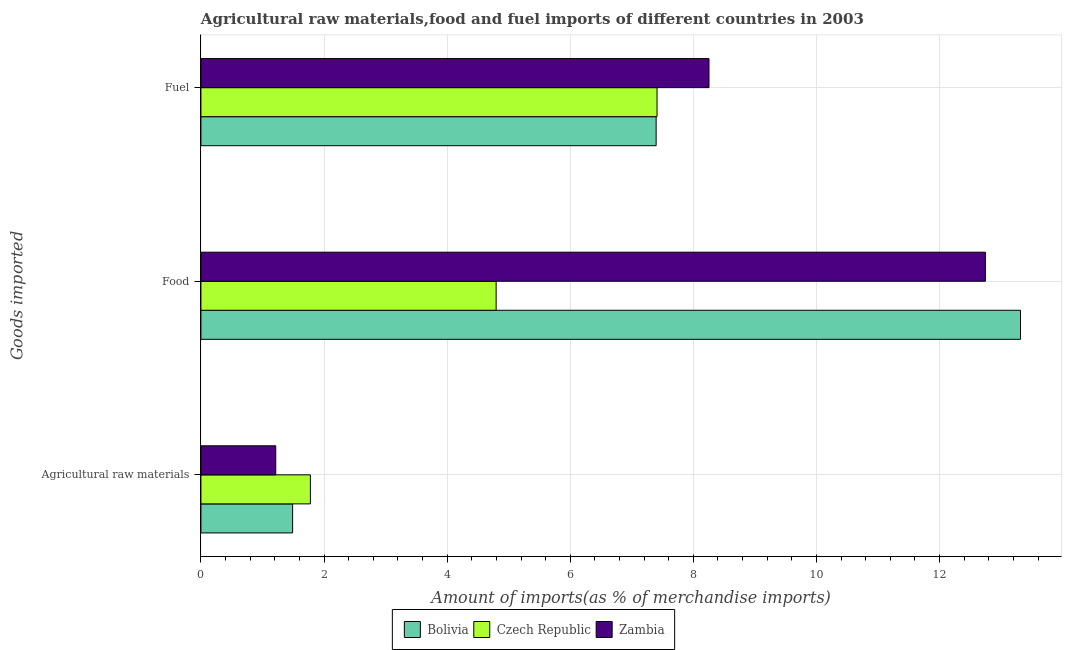How many different coloured bars are there?
Ensure brevity in your answer.  3. How many groups of bars are there?
Give a very brief answer. 3. Are the number of bars on each tick of the Y-axis equal?
Give a very brief answer. Yes. How many bars are there on the 3rd tick from the bottom?
Offer a very short reply. 3. What is the label of the 3rd group of bars from the top?
Provide a succinct answer. Agricultural raw materials. What is the percentage of raw materials imports in Zambia?
Make the answer very short. 1.22. Across all countries, what is the maximum percentage of food imports?
Provide a short and direct response. 13.31. Across all countries, what is the minimum percentage of food imports?
Offer a terse response. 4.8. In which country was the percentage of fuel imports maximum?
Offer a terse response. Zambia. In which country was the percentage of raw materials imports minimum?
Your response must be concise. Zambia. What is the total percentage of food imports in the graph?
Your answer should be compact. 30.86. What is the difference between the percentage of fuel imports in Czech Republic and that in Bolivia?
Your answer should be compact. 0.01. What is the difference between the percentage of raw materials imports in Zambia and the percentage of fuel imports in Czech Republic?
Provide a succinct answer. -6.19. What is the average percentage of raw materials imports per country?
Ensure brevity in your answer.  1.49. What is the difference between the percentage of raw materials imports and percentage of food imports in Bolivia?
Your response must be concise. -11.82. In how many countries, is the percentage of fuel imports greater than 9.2 %?
Provide a short and direct response. 0. What is the ratio of the percentage of fuel imports in Czech Republic to that in Bolivia?
Ensure brevity in your answer.  1. Is the percentage of food imports in Bolivia less than that in Zambia?
Make the answer very short. No. What is the difference between the highest and the second highest percentage of raw materials imports?
Ensure brevity in your answer.  0.29. What is the difference between the highest and the lowest percentage of fuel imports?
Your answer should be compact. 0.86. What does the 3rd bar from the top in Fuel represents?
Offer a very short reply. Bolivia. What does the 1st bar from the bottom in Fuel represents?
Provide a succinct answer. Bolivia. Is it the case that in every country, the sum of the percentage of raw materials imports and percentage of food imports is greater than the percentage of fuel imports?
Provide a short and direct response. No. How many bars are there?
Give a very brief answer. 9. Are all the bars in the graph horizontal?
Ensure brevity in your answer.  Yes. What is the difference between two consecutive major ticks on the X-axis?
Make the answer very short. 2. Does the graph contain grids?
Provide a succinct answer. Yes. How many legend labels are there?
Your answer should be compact. 3. What is the title of the graph?
Provide a short and direct response. Agricultural raw materials,food and fuel imports of different countries in 2003. Does "Central Europe" appear as one of the legend labels in the graph?
Offer a very short reply. No. What is the label or title of the X-axis?
Provide a succinct answer. Amount of imports(as % of merchandise imports). What is the label or title of the Y-axis?
Your answer should be very brief. Goods imported. What is the Amount of imports(as % of merchandise imports) of Bolivia in Agricultural raw materials?
Offer a very short reply. 1.49. What is the Amount of imports(as % of merchandise imports) of Czech Republic in Agricultural raw materials?
Give a very brief answer. 1.78. What is the Amount of imports(as % of merchandise imports) of Zambia in Agricultural raw materials?
Offer a terse response. 1.22. What is the Amount of imports(as % of merchandise imports) in Bolivia in Food?
Provide a short and direct response. 13.31. What is the Amount of imports(as % of merchandise imports) of Czech Republic in Food?
Offer a very short reply. 4.8. What is the Amount of imports(as % of merchandise imports) in Zambia in Food?
Give a very brief answer. 12.74. What is the Amount of imports(as % of merchandise imports) of Bolivia in Fuel?
Provide a succinct answer. 7.4. What is the Amount of imports(as % of merchandise imports) in Czech Republic in Fuel?
Make the answer very short. 7.41. What is the Amount of imports(as % of merchandise imports) in Zambia in Fuel?
Ensure brevity in your answer.  8.25. Across all Goods imported, what is the maximum Amount of imports(as % of merchandise imports) in Bolivia?
Provide a succinct answer. 13.31. Across all Goods imported, what is the maximum Amount of imports(as % of merchandise imports) of Czech Republic?
Provide a short and direct response. 7.41. Across all Goods imported, what is the maximum Amount of imports(as % of merchandise imports) of Zambia?
Offer a terse response. 12.74. Across all Goods imported, what is the minimum Amount of imports(as % of merchandise imports) in Bolivia?
Give a very brief answer. 1.49. Across all Goods imported, what is the minimum Amount of imports(as % of merchandise imports) in Czech Republic?
Keep it short and to the point. 1.78. Across all Goods imported, what is the minimum Amount of imports(as % of merchandise imports) in Zambia?
Ensure brevity in your answer.  1.22. What is the total Amount of imports(as % of merchandise imports) in Czech Republic in the graph?
Your answer should be very brief. 13.98. What is the total Amount of imports(as % of merchandise imports) of Zambia in the graph?
Keep it short and to the point. 22.21. What is the difference between the Amount of imports(as % of merchandise imports) in Bolivia in Agricultural raw materials and that in Food?
Make the answer very short. -11.82. What is the difference between the Amount of imports(as % of merchandise imports) of Czech Republic in Agricultural raw materials and that in Food?
Keep it short and to the point. -3.02. What is the difference between the Amount of imports(as % of merchandise imports) in Zambia in Agricultural raw materials and that in Food?
Offer a very short reply. -11.53. What is the difference between the Amount of imports(as % of merchandise imports) of Bolivia in Agricultural raw materials and that in Fuel?
Provide a succinct answer. -5.91. What is the difference between the Amount of imports(as % of merchandise imports) of Czech Republic in Agricultural raw materials and that in Fuel?
Your response must be concise. -5.63. What is the difference between the Amount of imports(as % of merchandise imports) in Zambia in Agricultural raw materials and that in Fuel?
Provide a short and direct response. -7.04. What is the difference between the Amount of imports(as % of merchandise imports) in Bolivia in Food and that in Fuel?
Make the answer very short. 5.92. What is the difference between the Amount of imports(as % of merchandise imports) of Czech Republic in Food and that in Fuel?
Make the answer very short. -2.61. What is the difference between the Amount of imports(as % of merchandise imports) of Zambia in Food and that in Fuel?
Your answer should be very brief. 4.49. What is the difference between the Amount of imports(as % of merchandise imports) in Bolivia in Agricultural raw materials and the Amount of imports(as % of merchandise imports) in Czech Republic in Food?
Offer a terse response. -3.31. What is the difference between the Amount of imports(as % of merchandise imports) of Bolivia in Agricultural raw materials and the Amount of imports(as % of merchandise imports) of Zambia in Food?
Your answer should be compact. -11.25. What is the difference between the Amount of imports(as % of merchandise imports) in Czech Republic in Agricultural raw materials and the Amount of imports(as % of merchandise imports) in Zambia in Food?
Provide a short and direct response. -10.97. What is the difference between the Amount of imports(as % of merchandise imports) in Bolivia in Agricultural raw materials and the Amount of imports(as % of merchandise imports) in Czech Republic in Fuel?
Your response must be concise. -5.92. What is the difference between the Amount of imports(as % of merchandise imports) in Bolivia in Agricultural raw materials and the Amount of imports(as % of merchandise imports) in Zambia in Fuel?
Your answer should be compact. -6.76. What is the difference between the Amount of imports(as % of merchandise imports) of Czech Republic in Agricultural raw materials and the Amount of imports(as % of merchandise imports) of Zambia in Fuel?
Your answer should be very brief. -6.48. What is the difference between the Amount of imports(as % of merchandise imports) of Bolivia in Food and the Amount of imports(as % of merchandise imports) of Czech Republic in Fuel?
Offer a very short reply. 5.9. What is the difference between the Amount of imports(as % of merchandise imports) of Bolivia in Food and the Amount of imports(as % of merchandise imports) of Zambia in Fuel?
Ensure brevity in your answer.  5.06. What is the difference between the Amount of imports(as % of merchandise imports) in Czech Republic in Food and the Amount of imports(as % of merchandise imports) in Zambia in Fuel?
Provide a short and direct response. -3.46. What is the average Amount of imports(as % of merchandise imports) of Czech Republic per Goods imported?
Provide a succinct answer. 4.66. What is the average Amount of imports(as % of merchandise imports) of Zambia per Goods imported?
Give a very brief answer. 7.4. What is the difference between the Amount of imports(as % of merchandise imports) in Bolivia and Amount of imports(as % of merchandise imports) in Czech Republic in Agricultural raw materials?
Your answer should be very brief. -0.29. What is the difference between the Amount of imports(as % of merchandise imports) in Bolivia and Amount of imports(as % of merchandise imports) in Zambia in Agricultural raw materials?
Your answer should be very brief. 0.27. What is the difference between the Amount of imports(as % of merchandise imports) of Czech Republic and Amount of imports(as % of merchandise imports) of Zambia in Agricultural raw materials?
Provide a short and direct response. 0.56. What is the difference between the Amount of imports(as % of merchandise imports) in Bolivia and Amount of imports(as % of merchandise imports) in Czech Republic in Food?
Your answer should be very brief. 8.52. What is the difference between the Amount of imports(as % of merchandise imports) of Bolivia and Amount of imports(as % of merchandise imports) of Zambia in Food?
Give a very brief answer. 0.57. What is the difference between the Amount of imports(as % of merchandise imports) of Czech Republic and Amount of imports(as % of merchandise imports) of Zambia in Food?
Your answer should be very brief. -7.95. What is the difference between the Amount of imports(as % of merchandise imports) in Bolivia and Amount of imports(as % of merchandise imports) in Czech Republic in Fuel?
Give a very brief answer. -0.01. What is the difference between the Amount of imports(as % of merchandise imports) in Bolivia and Amount of imports(as % of merchandise imports) in Zambia in Fuel?
Give a very brief answer. -0.86. What is the difference between the Amount of imports(as % of merchandise imports) of Czech Republic and Amount of imports(as % of merchandise imports) of Zambia in Fuel?
Provide a succinct answer. -0.84. What is the ratio of the Amount of imports(as % of merchandise imports) of Bolivia in Agricultural raw materials to that in Food?
Provide a short and direct response. 0.11. What is the ratio of the Amount of imports(as % of merchandise imports) of Czech Republic in Agricultural raw materials to that in Food?
Provide a short and direct response. 0.37. What is the ratio of the Amount of imports(as % of merchandise imports) in Zambia in Agricultural raw materials to that in Food?
Your answer should be compact. 0.1. What is the ratio of the Amount of imports(as % of merchandise imports) of Bolivia in Agricultural raw materials to that in Fuel?
Keep it short and to the point. 0.2. What is the ratio of the Amount of imports(as % of merchandise imports) of Czech Republic in Agricultural raw materials to that in Fuel?
Make the answer very short. 0.24. What is the ratio of the Amount of imports(as % of merchandise imports) in Zambia in Agricultural raw materials to that in Fuel?
Ensure brevity in your answer.  0.15. What is the ratio of the Amount of imports(as % of merchandise imports) of Bolivia in Food to that in Fuel?
Offer a terse response. 1.8. What is the ratio of the Amount of imports(as % of merchandise imports) of Czech Republic in Food to that in Fuel?
Offer a terse response. 0.65. What is the ratio of the Amount of imports(as % of merchandise imports) of Zambia in Food to that in Fuel?
Offer a very short reply. 1.54. What is the difference between the highest and the second highest Amount of imports(as % of merchandise imports) in Bolivia?
Your answer should be very brief. 5.92. What is the difference between the highest and the second highest Amount of imports(as % of merchandise imports) of Czech Republic?
Your answer should be very brief. 2.61. What is the difference between the highest and the second highest Amount of imports(as % of merchandise imports) in Zambia?
Your answer should be very brief. 4.49. What is the difference between the highest and the lowest Amount of imports(as % of merchandise imports) in Bolivia?
Keep it short and to the point. 11.82. What is the difference between the highest and the lowest Amount of imports(as % of merchandise imports) of Czech Republic?
Your answer should be compact. 5.63. What is the difference between the highest and the lowest Amount of imports(as % of merchandise imports) of Zambia?
Your response must be concise. 11.53. 